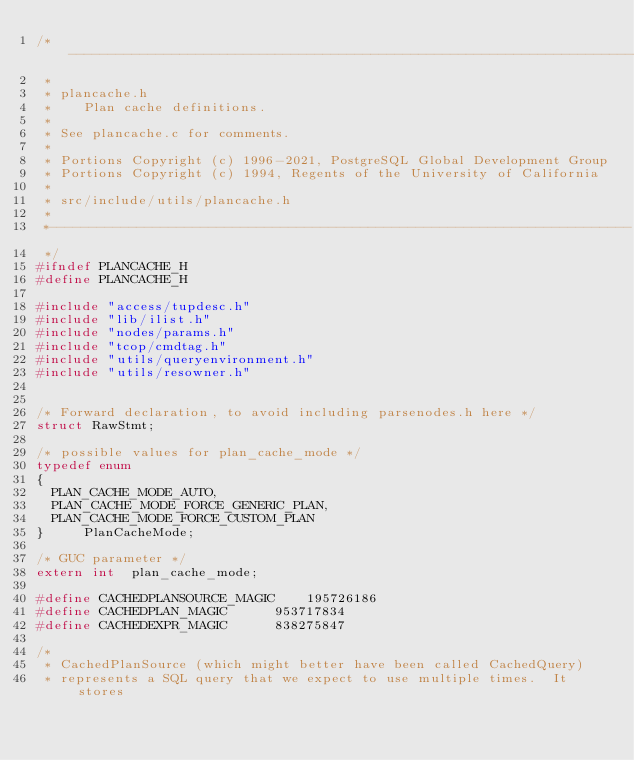<code> <loc_0><loc_0><loc_500><loc_500><_C_>/*-------------------------------------------------------------------------
 *
 * plancache.h
 *	  Plan cache definitions.
 *
 * See plancache.c for comments.
 *
 * Portions Copyright (c) 1996-2021, PostgreSQL Global Development Group
 * Portions Copyright (c) 1994, Regents of the University of California
 *
 * src/include/utils/plancache.h
 *
 *-------------------------------------------------------------------------
 */
#ifndef PLANCACHE_H
#define PLANCACHE_H

#include "access/tupdesc.h"
#include "lib/ilist.h"
#include "nodes/params.h"
#include "tcop/cmdtag.h"
#include "utils/queryenvironment.h"
#include "utils/resowner.h"


/* Forward declaration, to avoid including parsenodes.h here */
struct RawStmt;

/* possible values for plan_cache_mode */
typedef enum
{
	PLAN_CACHE_MODE_AUTO,
	PLAN_CACHE_MODE_FORCE_GENERIC_PLAN,
	PLAN_CACHE_MODE_FORCE_CUSTOM_PLAN
}			PlanCacheMode;

/* GUC parameter */
extern int	plan_cache_mode;

#define CACHEDPLANSOURCE_MAGIC		195726186
#define CACHEDPLAN_MAGIC			953717834
#define CACHEDEXPR_MAGIC			838275847

/*
 * CachedPlanSource (which might better have been called CachedQuery)
 * represents a SQL query that we expect to use multiple times.  It stores</code> 